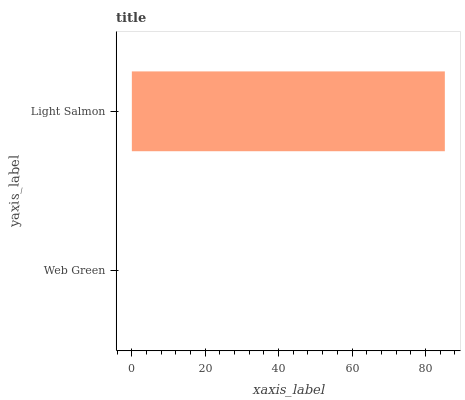Is Web Green the minimum?
Answer yes or no. Yes. Is Light Salmon the maximum?
Answer yes or no. Yes. Is Light Salmon the minimum?
Answer yes or no. No. Is Light Salmon greater than Web Green?
Answer yes or no. Yes. Is Web Green less than Light Salmon?
Answer yes or no. Yes. Is Web Green greater than Light Salmon?
Answer yes or no. No. Is Light Salmon less than Web Green?
Answer yes or no. No. Is Light Salmon the high median?
Answer yes or no. Yes. Is Web Green the low median?
Answer yes or no. Yes. Is Web Green the high median?
Answer yes or no. No. Is Light Salmon the low median?
Answer yes or no. No. 